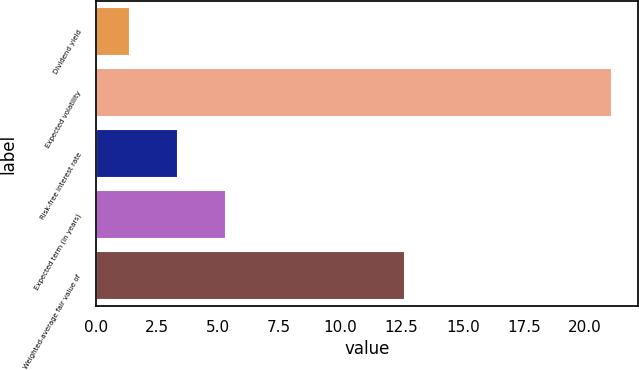<chart> <loc_0><loc_0><loc_500><loc_500><bar_chart><fcel>Dividend yield<fcel>Expected volatility<fcel>Risk-free interest rate<fcel>Expected term (in years)<fcel>Weighted-average fair value of<nl><fcel>1.4<fcel>21.1<fcel>3.37<fcel>5.34<fcel>12.63<nl></chart> 